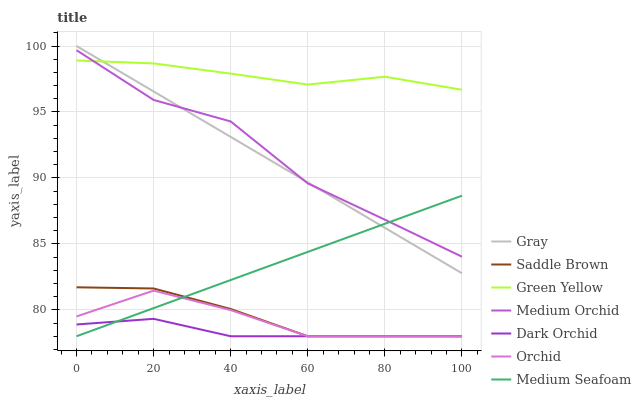Does Dark Orchid have the minimum area under the curve?
Answer yes or no. Yes. Does Green Yellow have the maximum area under the curve?
Answer yes or no. Yes. Does Medium Orchid have the minimum area under the curve?
Answer yes or no. No. Does Medium Orchid have the maximum area under the curve?
Answer yes or no. No. Is Medium Seafoam the smoothest?
Answer yes or no. Yes. Is Medium Orchid the roughest?
Answer yes or no. Yes. Is Dark Orchid the smoothest?
Answer yes or no. No. Is Dark Orchid the roughest?
Answer yes or no. No. Does Medium Orchid have the lowest value?
Answer yes or no. No. Does Gray have the highest value?
Answer yes or no. Yes. Does Medium Orchid have the highest value?
Answer yes or no. No. Is Saddle Brown less than Green Yellow?
Answer yes or no. Yes. Is Green Yellow greater than Orchid?
Answer yes or no. Yes. Does Medium Seafoam intersect Gray?
Answer yes or no. Yes. Is Medium Seafoam less than Gray?
Answer yes or no. No. Is Medium Seafoam greater than Gray?
Answer yes or no. No. Does Saddle Brown intersect Green Yellow?
Answer yes or no. No. 